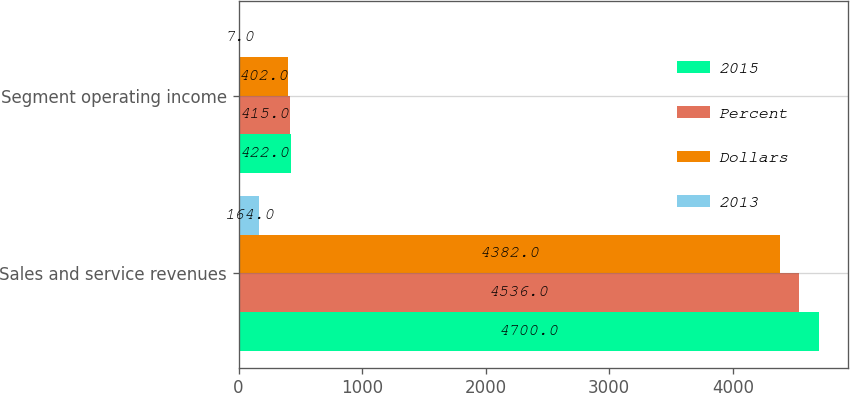Convert chart. <chart><loc_0><loc_0><loc_500><loc_500><stacked_bar_chart><ecel><fcel>Sales and service revenues<fcel>Segment operating income<nl><fcel>2015<fcel>4700<fcel>422<nl><fcel>Percent<fcel>4536<fcel>415<nl><fcel>Dollars<fcel>4382<fcel>402<nl><fcel>2013<fcel>164<fcel>7<nl></chart> 